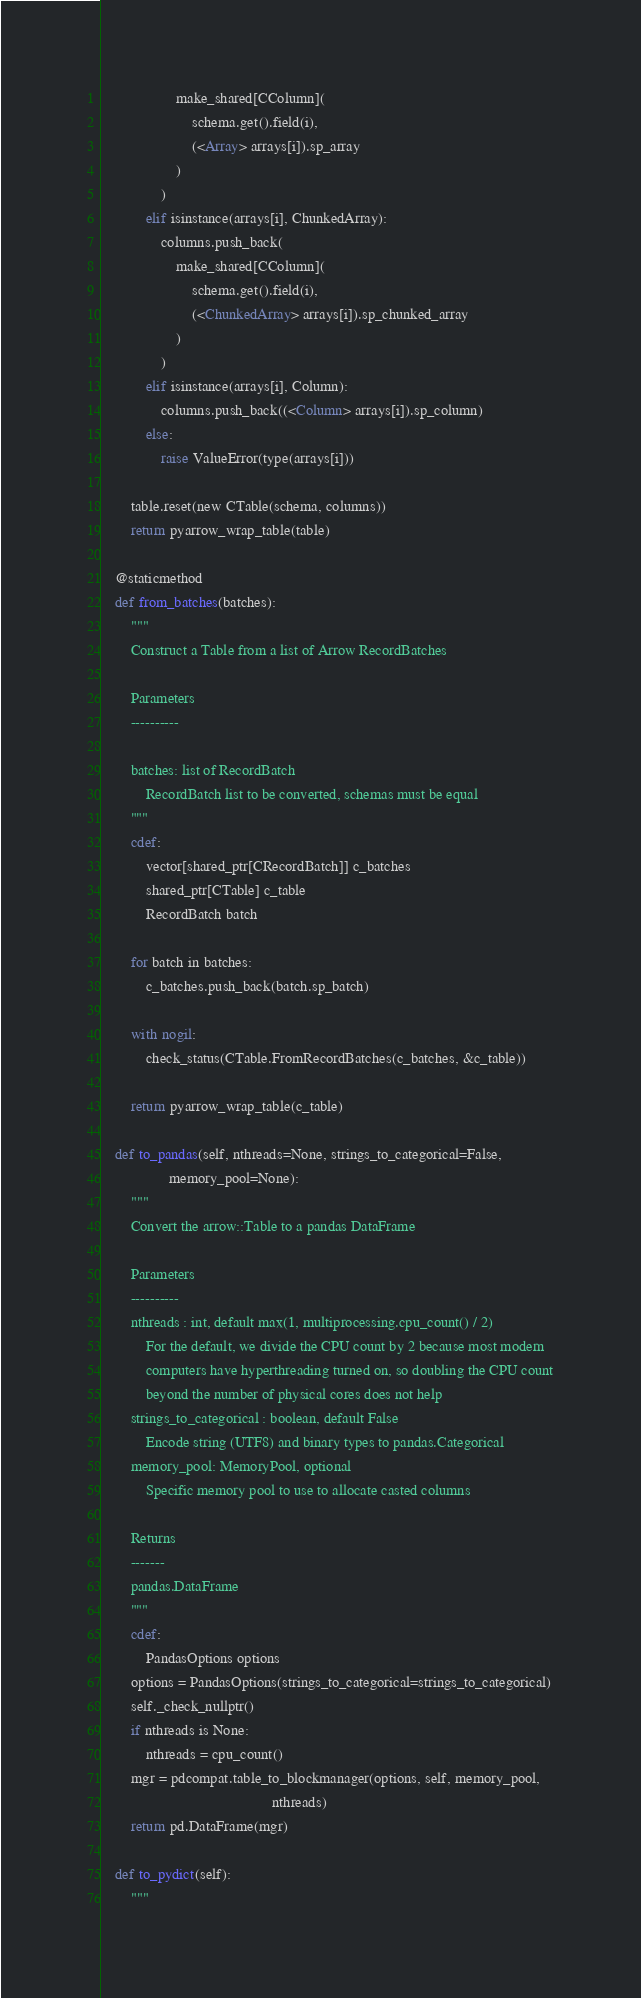<code> <loc_0><loc_0><loc_500><loc_500><_Cython_>                    make_shared[CColumn](
                        schema.get().field(i),
                        (<Array> arrays[i]).sp_array
                    )
                )
            elif isinstance(arrays[i], ChunkedArray):
                columns.push_back(
                    make_shared[CColumn](
                        schema.get().field(i),
                        (<ChunkedArray> arrays[i]).sp_chunked_array
                    )
                )
            elif isinstance(arrays[i], Column):
                columns.push_back((<Column> arrays[i]).sp_column)
            else:
                raise ValueError(type(arrays[i]))

        table.reset(new CTable(schema, columns))
        return pyarrow_wrap_table(table)

    @staticmethod
    def from_batches(batches):
        """
        Construct a Table from a list of Arrow RecordBatches

        Parameters
        ----------

        batches: list of RecordBatch
            RecordBatch list to be converted, schemas must be equal
        """
        cdef:
            vector[shared_ptr[CRecordBatch]] c_batches
            shared_ptr[CTable] c_table
            RecordBatch batch

        for batch in batches:
            c_batches.push_back(batch.sp_batch)

        with nogil:
            check_status(CTable.FromRecordBatches(c_batches, &c_table))

        return pyarrow_wrap_table(c_table)

    def to_pandas(self, nthreads=None, strings_to_categorical=False,
                  memory_pool=None):
        """
        Convert the arrow::Table to a pandas DataFrame

        Parameters
        ----------
        nthreads : int, default max(1, multiprocessing.cpu_count() / 2)
            For the default, we divide the CPU count by 2 because most modern
            computers have hyperthreading turned on, so doubling the CPU count
            beyond the number of physical cores does not help
        strings_to_categorical : boolean, default False
            Encode string (UTF8) and binary types to pandas.Categorical
        memory_pool: MemoryPool, optional
            Specific memory pool to use to allocate casted columns

        Returns
        -------
        pandas.DataFrame
        """
        cdef:
            PandasOptions options
        options = PandasOptions(strings_to_categorical=strings_to_categorical)
        self._check_nullptr()
        if nthreads is None:
            nthreads = cpu_count()
        mgr = pdcompat.table_to_blockmanager(options, self, memory_pool,
                                             nthreads)
        return pd.DataFrame(mgr)

    def to_pydict(self):
        """</code> 